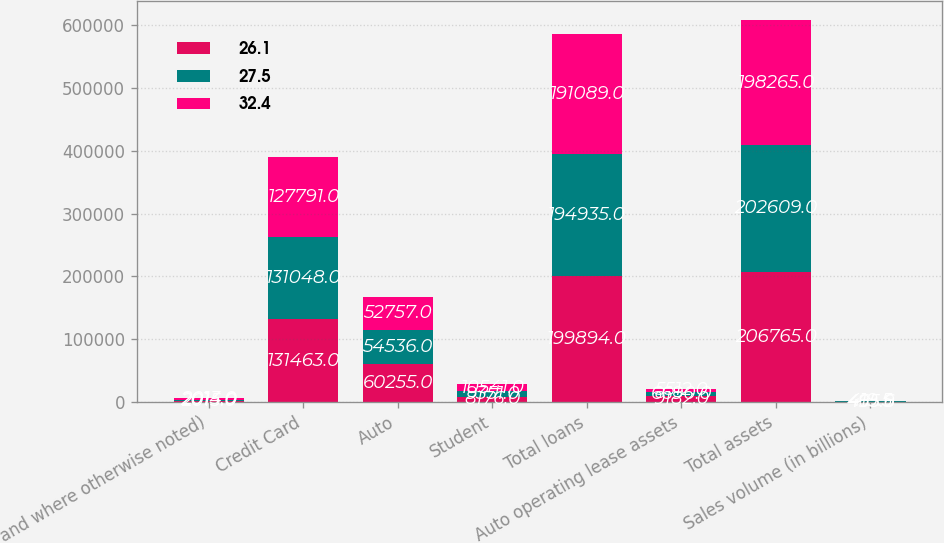Convert chart. <chart><loc_0><loc_0><loc_500><loc_500><stacked_bar_chart><ecel><fcel>and where otherwise noted)<fcel>Credit Card<fcel>Auto<fcel>Student<fcel>Total loans<fcel>Auto operating lease assets<fcel>Total assets<fcel>Sales volume (in billions)<nl><fcel>26.1<fcel>2015<fcel>131463<fcel>60255<fcel>8176<fcel>199894<fcel>9182<fcel>206765<fcel>495.9<nl><fcel>27.5<fcel>2014<fcel>131048<fcel>54536<fcel>9351<fcel>194935<fcel>6690<fcel>202609<fcel>465.6<nl><fcel>32.4<fcel>2013<fcel>127791<fcel>52757<fcel>10541<fcel>191089<fcel>5512<fcel>198265<fcel>419.5<nl></chart> 